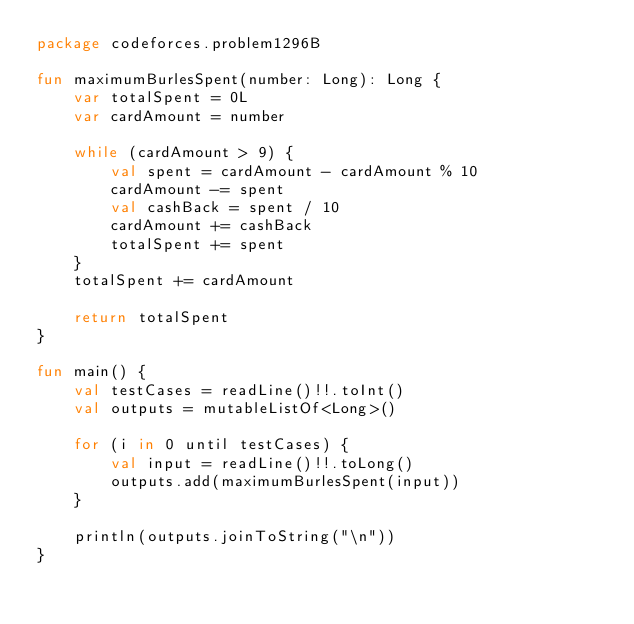<code> <loc_0><loc_0><loc_500><loc_500><_Kotlin_>package codeforces.problem1296B

fun maximumBurlesSpent(number: Long): Long {
    var totalSpent = 0L
    var cardAmount = number

    while (cardAmount > 9) {
        val spent = cardAmount - cardAmount % 10
        cardAmount -= spent
        val cashBack = spent / 10
        cardAmount += cashBack
        totalSpent += spent
    }
    totalSpent += cardAmount

    return totalSpent
}

fun main() {
    val testCases = readLine()!!.toInt()
    val outputs = mutableListOf<Long>()

    for (i in 0 until testCases) {
        val input = readLine()!!.toLong()
        outputs.add(maximumBurlesSpent(input))
    }

    println(outputs.joinToString("\n"))
}
</code> 